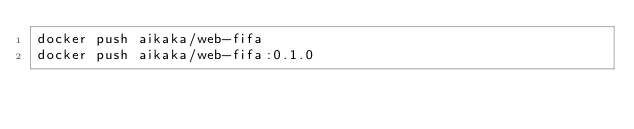<code> <loc_0><loc_0><loc_500><loc_500><_Bash_>docker push aikaka/web-fifa
docker push aikaka/web-fifa:0.1.0
</code> 